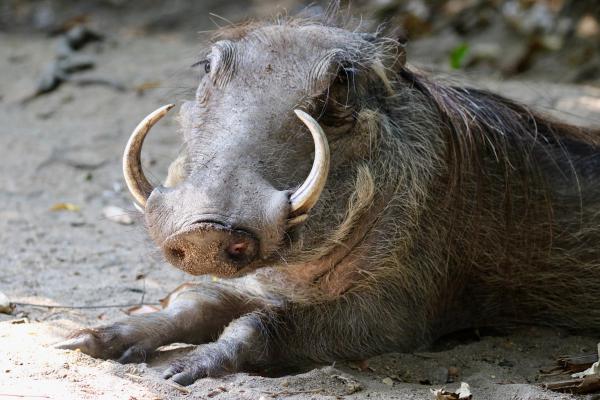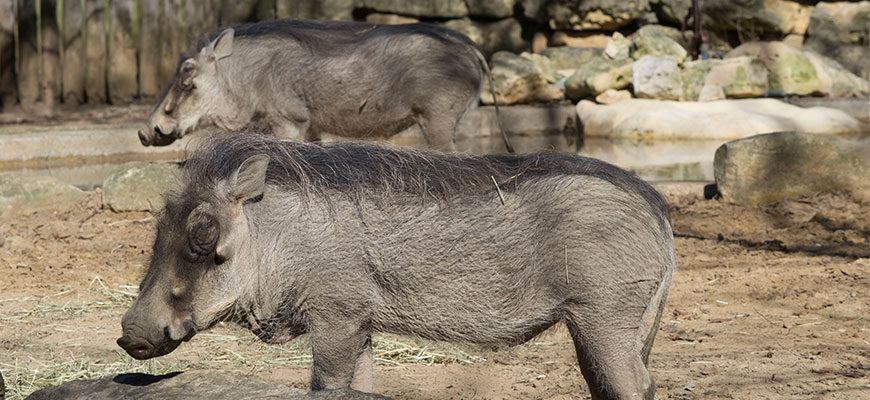The first image is the image on the left, the second image is the image on the right. Evaluate the accuracy of this statement regarding the images: "An image shows at least one warthog in profile, running across a dry field with its tail flying out behind it.". Is it true? Answer yes or no. No. 